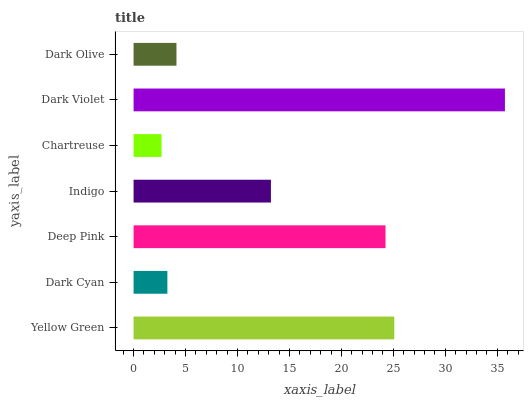Is Chartreuse the minimum?
Answer yes or no. Yes. Is Dark Violet the maximum?
Answer yes or no. Yes. Is Dark Cyan the minimum?
Answer yes or no. No. Is Dark Cyan the maximum?
Answer yes or no. No. Is Yellow Green greater than Dark Cyan?
Answer yes or no. Yes. Is Dark Cyan less than Yellow Green?
Answer yes or no. Yes. Is Dark Cyan greater than Yellow Green?
Answer yes or no. No. Is Yellow Green less than Dark Cyan?
Answer yes or no. No. Is Indigo the high median?
Answer yes or no. Yes. Is Indigo the low median?
Answer yes or no. Yes. Is Yellow Green the high median?
Answer yes or no. No. Is Chartreuse the low median?
Answer yes or no. No. 